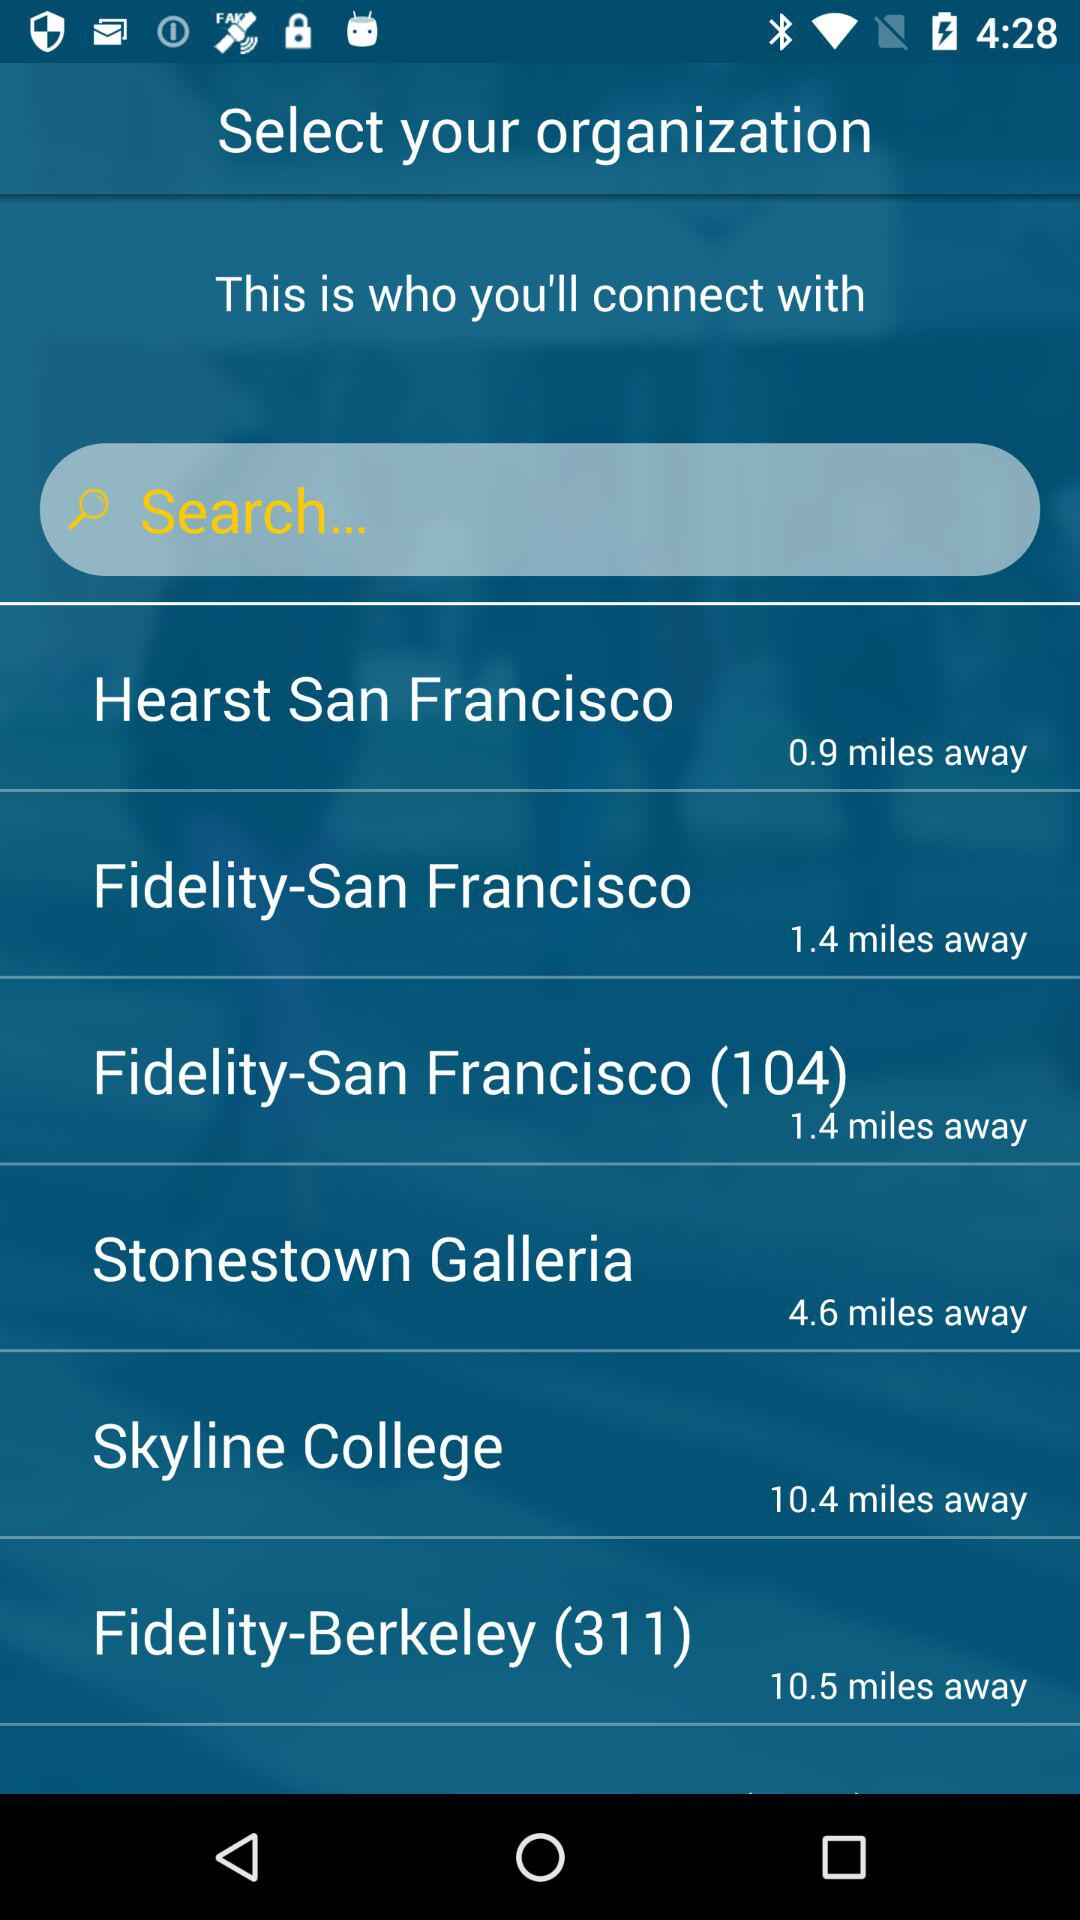What organization on the screen has (104) written after their name? The organization is Fidelity-San Francisco. 